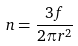Convert formula to latex. <formula><loc_0><loc_0><loc_500><loc_500>n = \frac { 3 f } { 2 \pi r ^ { 2 } }</formula> 